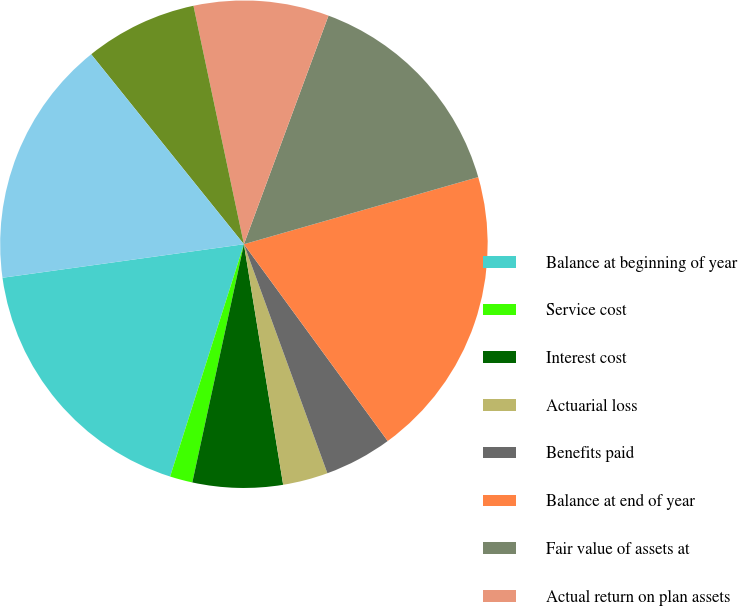<chart> <loc_0><loc_0><loc_500><loc_500><pie_chart><fcel>Balance at beginning of year<fcel>Service cost<fcel>Interest cost<fcel>Actuarial loss<fcel>Benefits paid<fcel>Balance at end of year<fcel>Fair value of assets at<fcel>Actual return on plan assets<fcel>Employer contributions<fcel>Fair value of assets at end of<nl><fcel>17.91%<fcel>1.5%<fcel>5.97%<fcel>2.99%<fcel>4.48%<fcel>19.4%<fcel>14.92%<fcel>8.96%<fcel>7.46%<fcel>16.42%<nl></chart> 